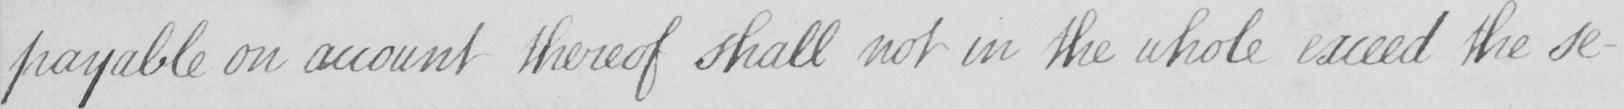Can you read and transcribe this handwriting? payable on account thereof shall not in the whole exceed the se- 